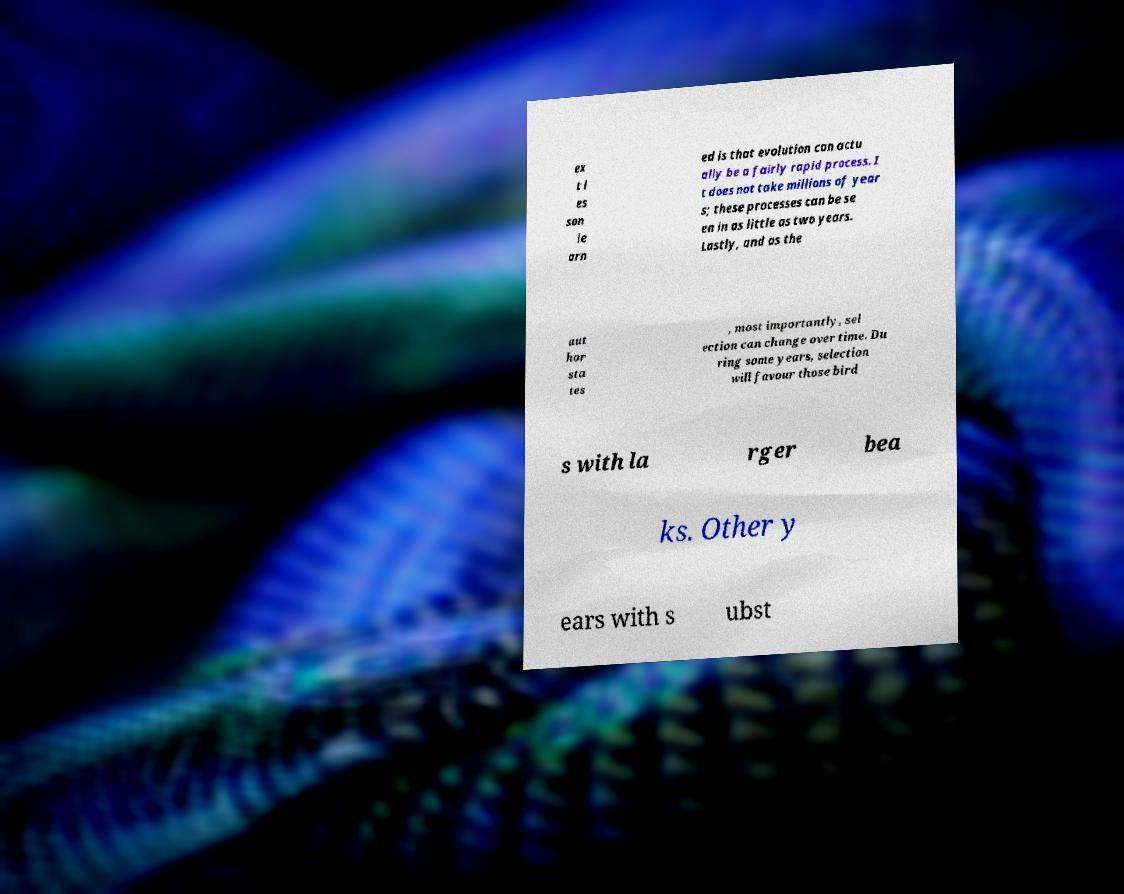For documentation purposes, I need the text within this image transcribed. Could you provide that? ex t l es son le arn ed is that evolution can actu ally be a fairly rapid process. I t does not take millions of year s; these processes can be se en in as little as two years. Lastly, and as the aut hor sta tes , most importantly, sel ection can change over time. Du ring some years, selection will favour those bird s with la rger bea ks. Other y ears with s ubst 